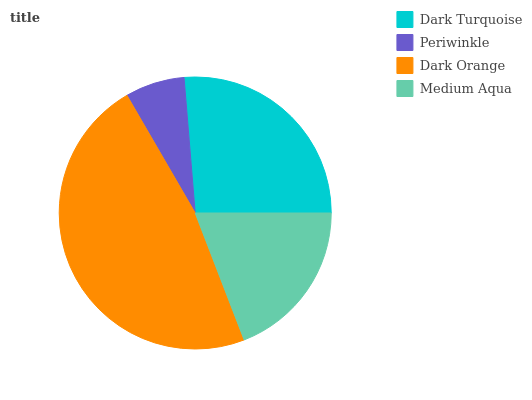Is Periwinkle the minimum?
Answer yes or no. Yes. Is Dark Orange the maximum?
Answer yes or no. Yes. Is Dark Orange the minimum?
Answer yes or no. No. Is Periwinkle the maximum?
Answer yes or no. No. Is Dark Orange greater than Periwinkle?
Answer yes or no. Yes. Is Periwinkle less than Dark Orange?
Answer yes or no. Yes. Is Periwinkle greater than Dark Orange?
Answer yes or no. No. Is Dark Orange less than Periwinkle?
Answer yes or no. No. Is Dark Turquoise the high median?
Answer yes or no. Yes. Is Medium Aqua the low median?
Answer yes or no. Yes. Is Periwinkle the high median?
Answer yes or no. No. Is Dark Turquoise the low median?
Answer yes or no. No. 